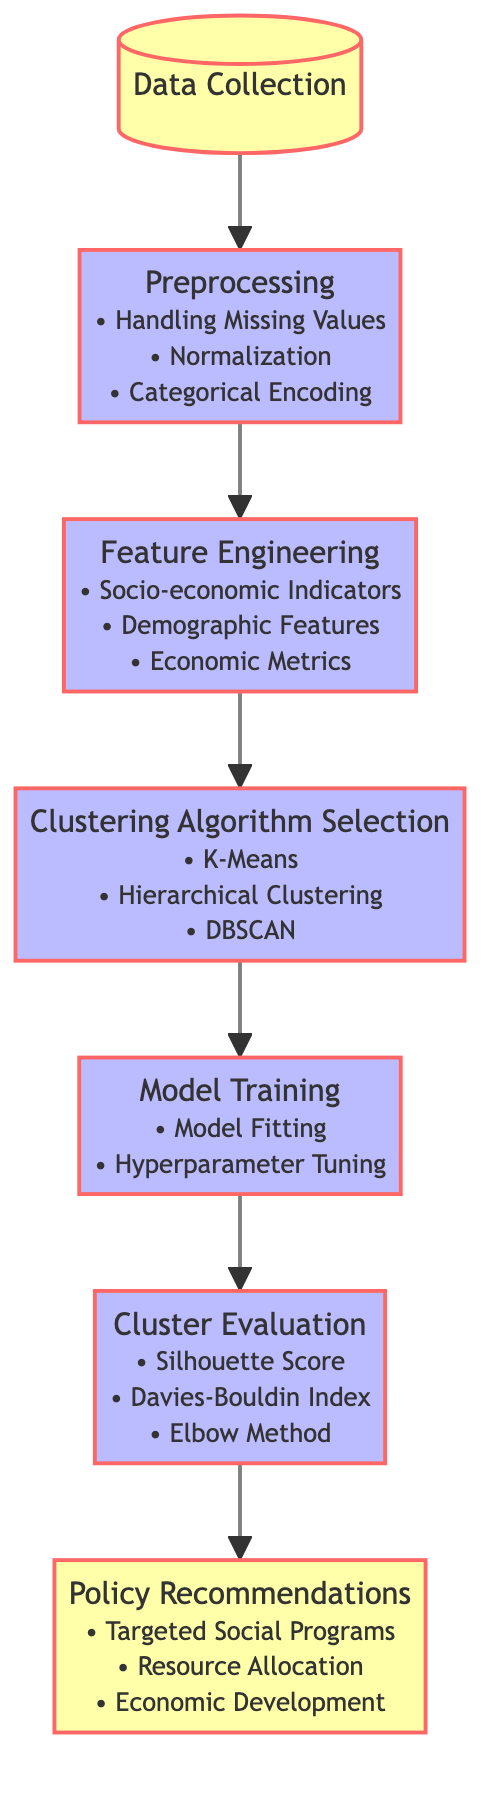What is the first step in the process? The diagram starts with the node labeled "Data Collection," indicating that this is the first step in the process of analyzing socio-economic data.
Answer: Data Collection How many types of clustering algorithms are mentioned? There are three types of clustering algorithms mentioned in the diagram: K-Means, Hierarchical Clustering, and DBSCAN.
Answer: Three What is the last step described in the diagram? The final step in the diagram is "Policy Recommendations," which summarizes the outcomes of the analysis process.
Answer: Policy Recommendations What are two tasks associated with Feature Engineering? The diagram outlines that Feature Engineering includes "Socio-economic Indicators" and "Demographic Features" as part of its tasks.
Answer: Socio-economic Indicators, Demographic Features Which evaluation method uses a score for clustering models? The "Silhouette Score" is one of the evaluation methods listed in the diagram that utilizes scoring to assess clustering models.
Answer: Silhouette Score How does the data flow from Data Collection to the last step? The data flows sequentially from "Data Collection" to "Preprocessing," "Feature Engineering," "Clustering Algorithm Selection," "Model Training," "Cluster Evaluation," and finally "Policy Recommendations," indicating a linear progression through the steps.
Answer: Linear progression What are the three aspects included in the Cluster Evaluation? The three aspects included in Cluster Evaluation are "Silhouette Score," "Davies-Bouldin Index," and "Elbow Method," where each aspect contributes to evaluating the clustering performance.
Answer: Silhouette Score, Davies-Bouldin Index, Elbow Method What does Model Training focus on? Model Training in the diagram focuses on "Model Fitting" and "Hyperparameter Tuning," indicating the critical tasks involved in training the machine learning model.
Answer: Model Fitting, Hyperparameter Tuning 